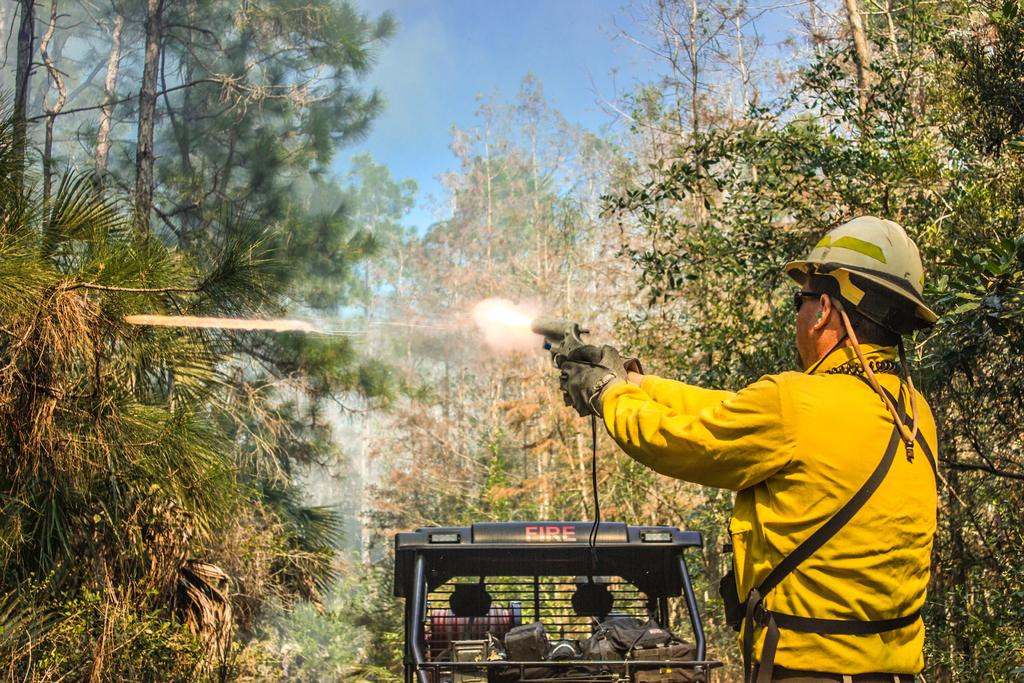What is the person in the image doing? The person is standing and holding a gun. What is the person doing with the gun? The person is shooting something with the gun. What can be seen in the background of the image? There is a vehicle, trees, plants, and the sky visible in the background of the image. What is inside the vehicle? The vehicle has bags in it. What type of decision is the person making while holding the gun in the image? There is no indication in the image that the person is making a decision; they are simply holding and shooting the gun. Can you tell me what flavor of popcorn is being served in the image? There is no popcorn present in the image. 